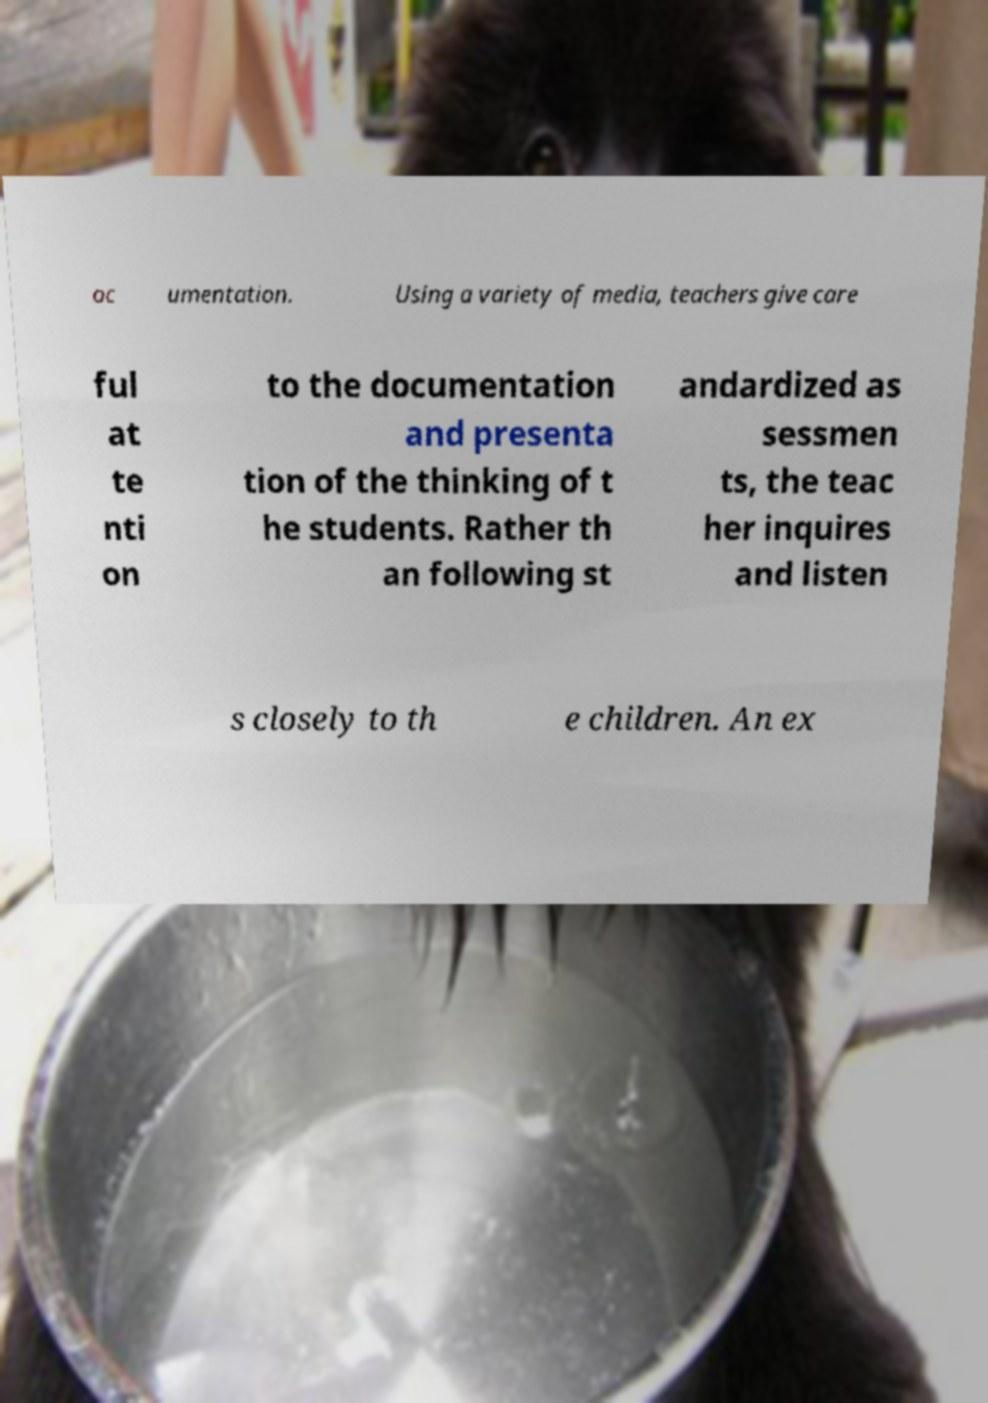There's text embedded in this image that I need extracted. Can you transcribe it verbatim? oc umentation. Using a variety of media, teachers give care ful at te nti on to the documentation and presenta tion of the thinking of t he students. Rather th an following st andardized as sessmen ts, the teac her inquires and listen s closely to th e children. An ex 